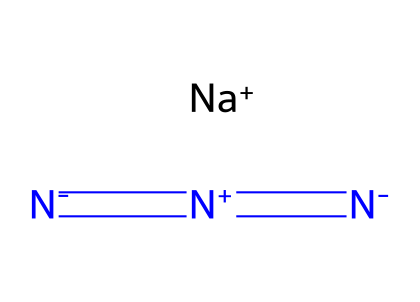What is the molecular formula of sodium azide? The SMILES representation indicates there is one sodium atom (Na) and three nitrogen atoms (N), leading to the molecular formula NaN3.
Answer: NaN3 How many nitrogen atoms are present in sodium azide? From the SMILES representation, we can count three nitrogen atoms, as indicated by the three 'N' symbols.
Answer: 3 What type of bond connects the nitrogen atoms in sodium azide? The SMILES structure shows the nitrogen atoms connected by double bonds, as evidenced by the '=' symbols, indicating the presence of double bonds between the nitrogen atoms.
Answer: double bonds What charge does sodium carry in sodium azide? The notation “[Na+]” in the SMILES indicates that sodium carries a positive charge.
Answer: positive Why is sodium azide classified as an azide? Sodium azide contains the azide functional group, which is defined by the presence of three nitrogen atoms connected in a sequence, represented as [-N=N=N-] in the structure.
Answer: azide group What role does sodium azide play in airbags? Sodium azide decomposes rapidly to produce nitrogen gas when triggered, which inflates airbags quickly in a car accident, making it essential for this safety feature.
Answer: propellant What does the presence of the sodium ion indicate about the solubility of sodium azide? The sodium ion makes sodium azide soluble in water since it forms an ionic compound that can dissociate, allowing for easy dissolution in aqueous solutions.
Answer: soluble 